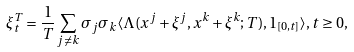Convert formula to latex. <formula><loc_0><loc_0><loc_500><loc_500>\xi _ { t } ^ { T } = \frac { 1 } { T } \sum _ { j \neq k } \sigma _ { j } \sigma _ { k } \langle \Lambda ( x ^ { j } + \xi ^ { j } , x ^ { k } + \xi ^ { k } ; T ) , 1 _ { [ 0 , t ] } \rangle , t \geq 0 ,</formula> 